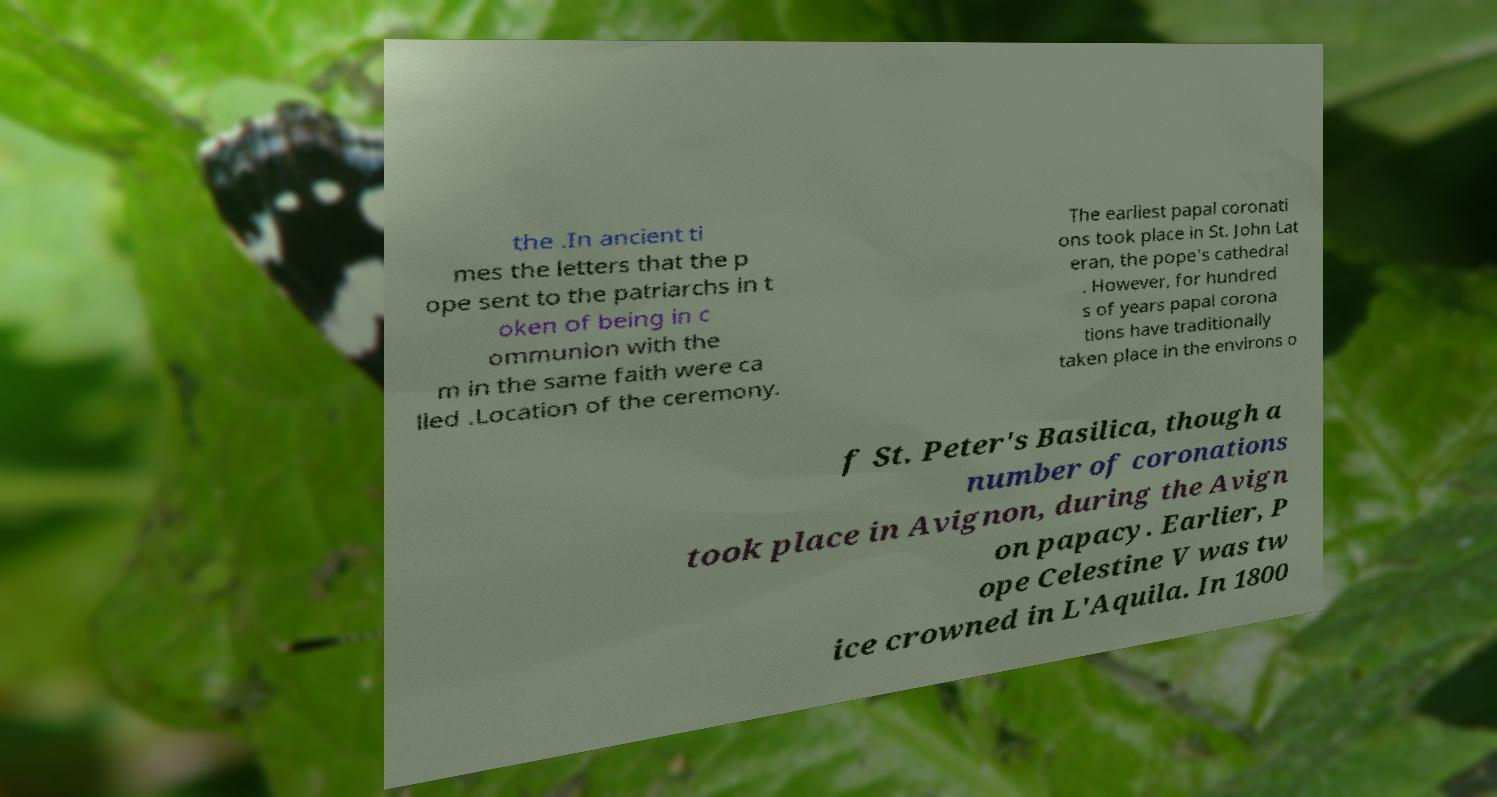Please read and relay the text visible in this image. What does it say? the .In ancient ti mes the letters that the p ope sent to the patriarchs in t oken of being in c ommunion with the m in the same faith were ca lled .Location of the ceremony. The earliest papal coronati ons took place in St. John Lat eran, the pope's cathedral . However, for hundred s of years papal corona tions have traditionally taken place in the environs o f St. Peter's Basilica, though a number of coronations took place in Avignon, during the Avign on papacy. Earlier, P ope Celestine V was tw ice crowned in L'Aquila. In 1800 